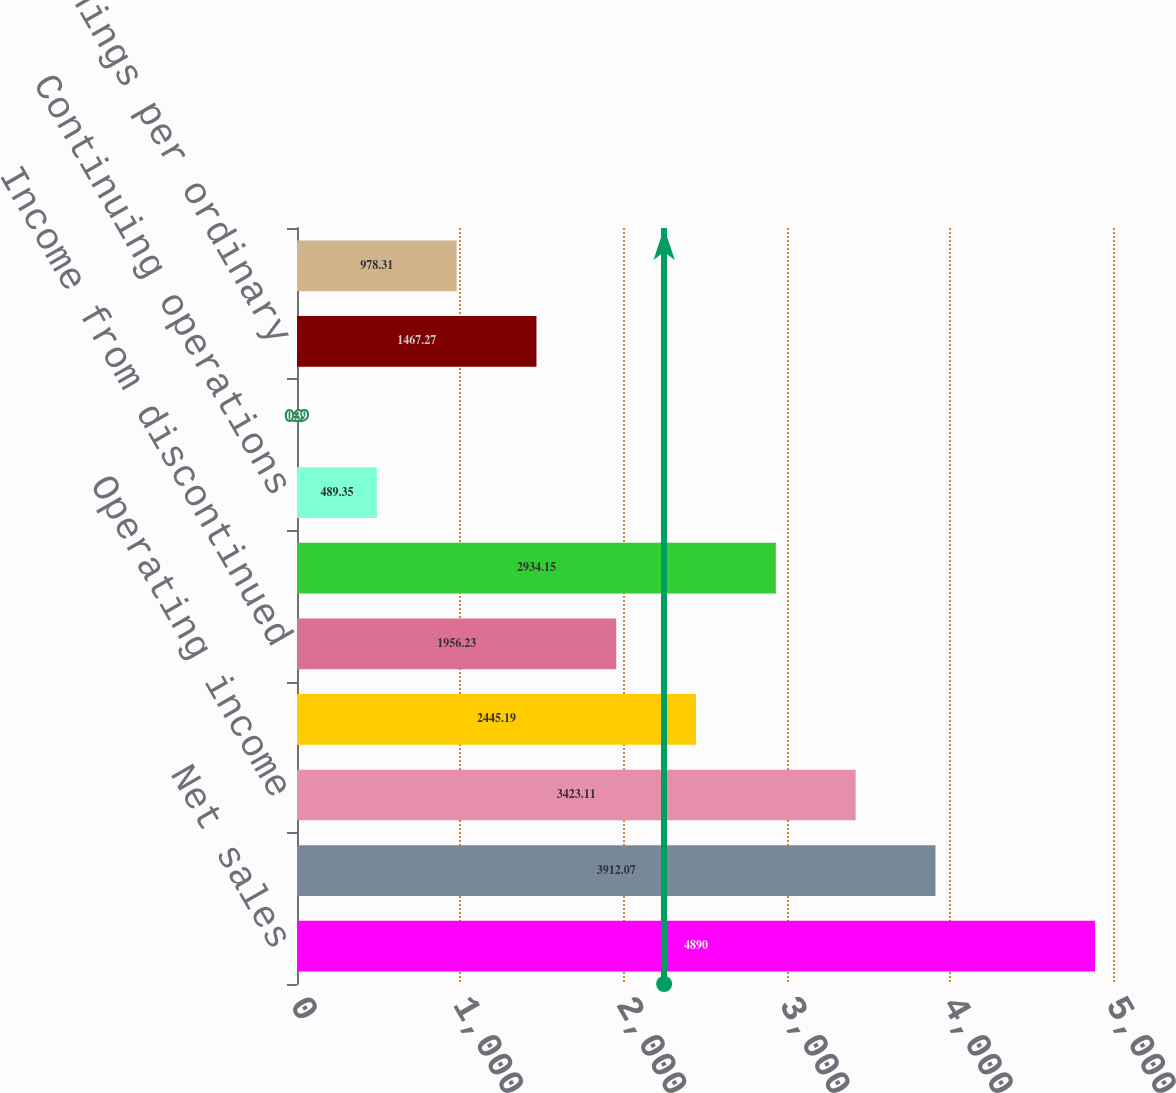<chart> <loc_0><loc_0><loc_500><loc_500><bar_chart><fcel>Net sales<fcel>Gross profit<fcel>Operating income<fcel>Net income from continuing<fcel>Income from discontinued<fcel>Net income<fcel>Continuing operations<fcel>Discontinued operations<fcel>Basic earnings per ordinary<fcel>Diluted earnings per ordinary<nl><fcel>4890<fcel>3912.07<fcel>3423.11<fcel>2445.19<fcel>1956.23<fcel>2934.15<fcel>489.35<fcel>0.39<fcel>1467.27<fcel>978.31<nl></chart> 